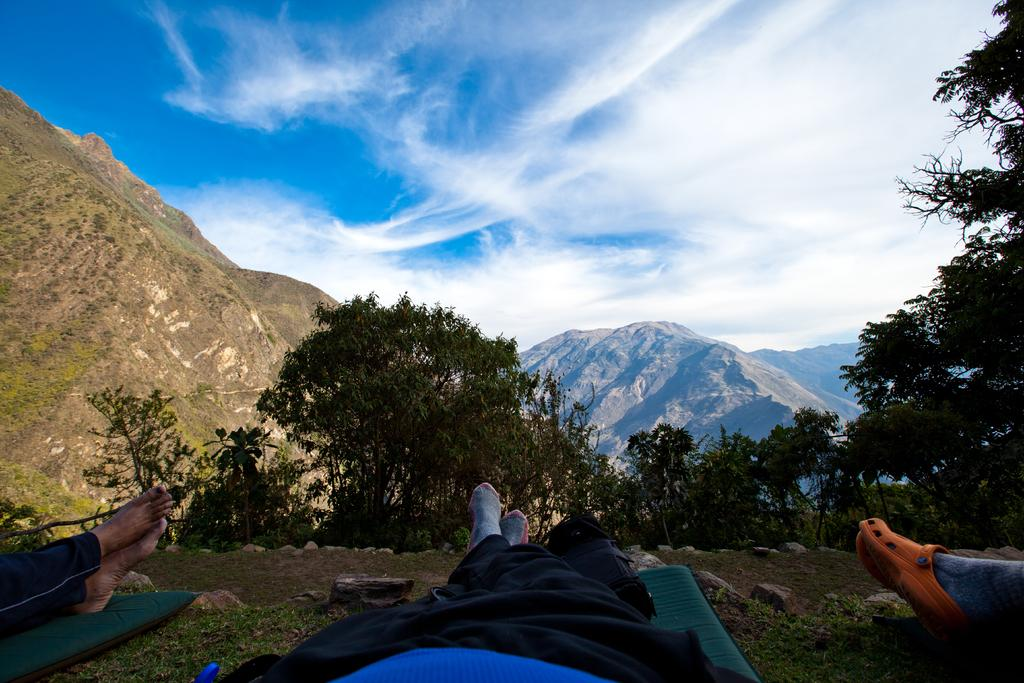What type of natural vegetation is present in the image? There are trees in the image. How many people can be inferred to be in the image? There are three pairs of legs on the ground, indicating three persons. What type of geographical feature can be seen in the distance? There are mountains in the image. What is the condition of the sky in the image? The sky is cloudy. What type of celery is being used as a pen in the image? There is no celery or pen present in the image. What desires are being expressed by the people in the image? The image does not provide any information about the desires of the people. 